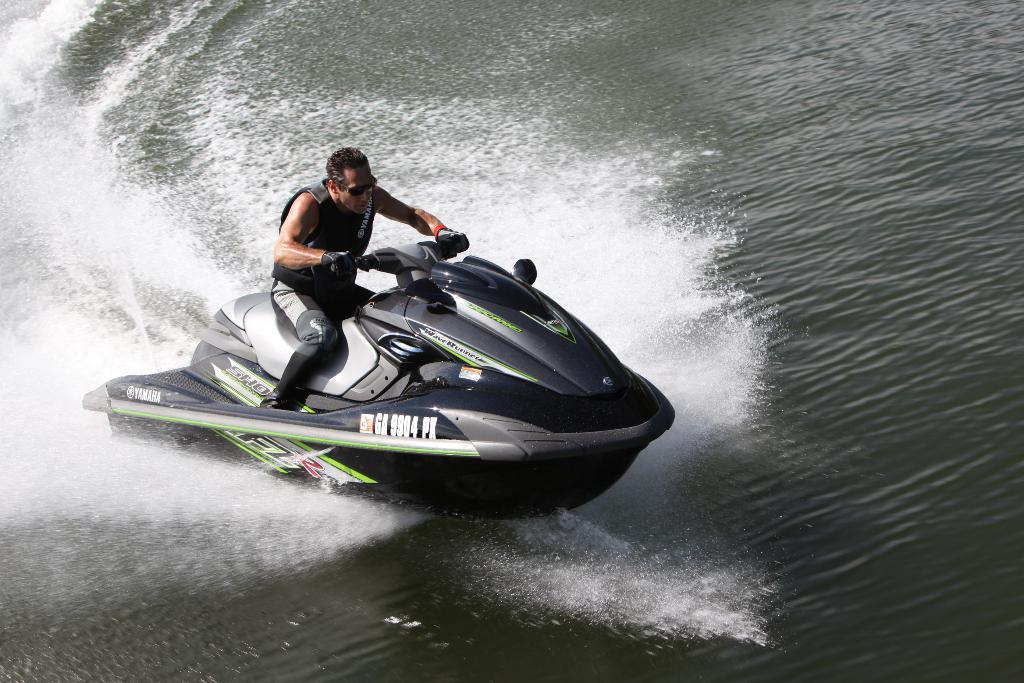Who is present in the image? There is a man in the picture. What is the man doing in the image? The man is sitting on a motor boat. Where is the motor boat located? The motor boat is on the water. What type of fruit is being protested against in the image? There is no protest or fruit present in the image; it features a man sitting on a motor boat on the water. 